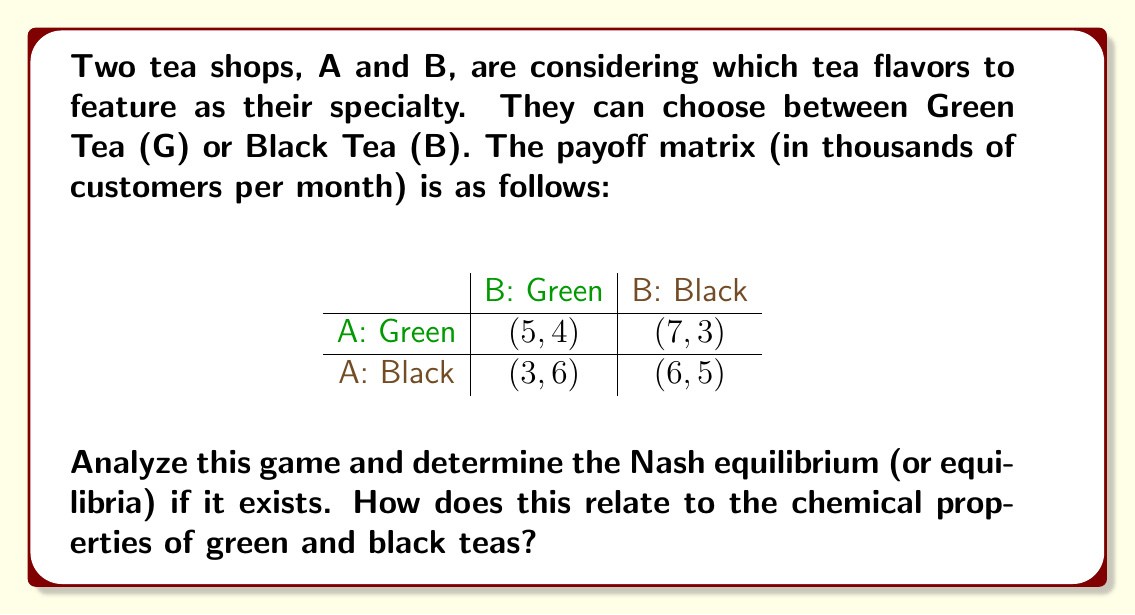Give your solution to this math problem. To find the Nash equilibrium, we need to analyze each player's best response to the other player's strategies.

1. For Shop A:
   - If B chooses Green: A's best response is Green (5 > 3)
   - If B chooses Black: A's best response is Green (7 > 6)

2. For Shop B:
   - If A chooses Green: B's best response is Green (4 > 3)
   - If A chooses Black: B's best response is Green (6 > 5)

We can see that regardless of what the other player does, both shops have a dominant strategy of choosing Green Tea. Therefore, the Nash equilibrium is (Green, Green) with payoffs (5, 4).

This relates to the chemical properties of teas as follows:

Green tea contains higher levels of catechins, particularly epigallocatechin gallate (EGCG), which are potent antioxidants. These compounds are responsible for the fresh, slightly astringent flavor of green tea. During the oxidation process that creates black tea, these catechins are converted into theaflavins and thearubigins, which give black tea its darker color and more robust flavor.

The Nash equilibrium favoring green tea could reflect a growing consumer preference for the health benefits associated with green tea's higher antioxidant content. Additionally, the lighter flavor profile of green tea might be more appealing to a wider range of customers, explaining its dominance in this market model.
Answer: The Nash equilibrium is (Green, Green) with payoffs (5, 4), reflecting both shops choosing to specialize in green tea due to its chemical properties and consumer preferences. 